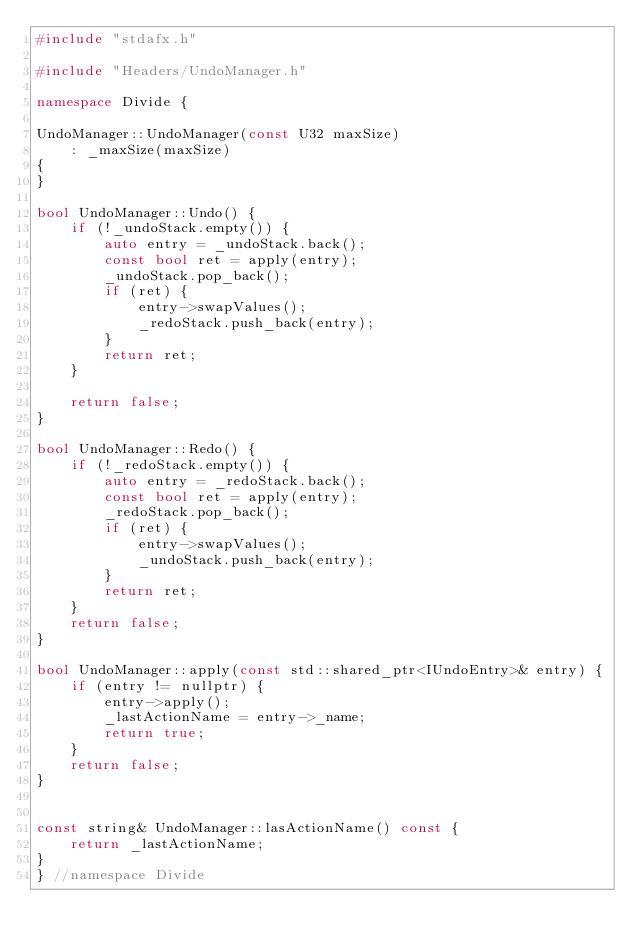Convert code to text. <code><loc_0><loc_0><loc_500><loc_500><_C++_>#include "stdafx.h"

#include "Headers/UndoManager.h"

namespace Divide {

UndoManager::UndoManager(const U32 maxSize)
    : _maxSize(maxSize)
{
}

bool UndoManager::Undo() {
    if (!_undoStack.empty()) {
        auto entry = _undoStack.back();
        const bool ret = apply(entry);
        _undoStack.pop_back();
        if (ret) {
            entry->swapValues();
            _redoStack.push_back(entry);
        }
        return ret;
    }

    return false;
}

bool UndoManager::Redo() {
    if (!_redoStack.empty()) {
        auto entry = _redoStack.back();
        const bool ret = apply(entry);
        _redoStack.pop_back();
        if (ret) {
            entry->swapValues();
            _undoStack.push_back(entry);
        }
        return ret;
    }
    return false;
}

bool UndoManager::apply(const std::shared_ptr<IUndoEntry>& entry) {
    if (entry != nullptr) {
        entry->apply();
        _lastActionName = entry->_name;
        return true;
    }
    return false;
}


const string& UndoManager::lasActionName() const {
    return _lastActionName;
}
} //namespace Divide </code> 